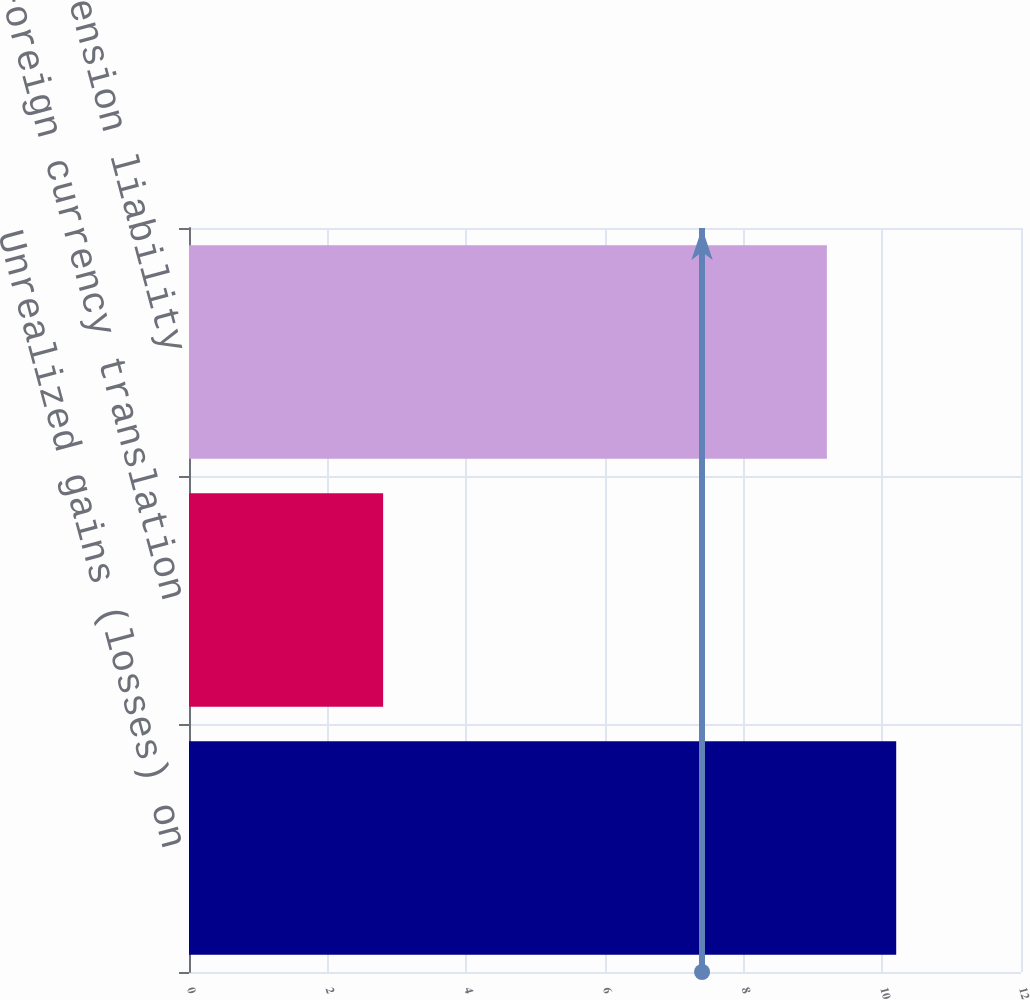Convert chart to OTSL. <chart><loc_0><loc_0><loc_500><loc_500><bar_chart><fcel>Unrealized gains (losses) on<fcel>Foreign currency translation<fcel>Minimum pension liability<nl><fcel>10.2<fcel>2.8<fcel>9.2<nl></chart> 